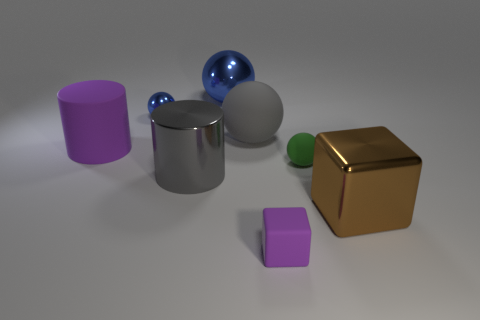Subtract all small green balls. How many balls are left? 3 Subtract all purple cylinders. How many cylinders are left? 1 Add 2 small red metal objects. How many objects exist? 10 Subtract all cylinders. How many objects are left? 6 Subtract all green cylinders. How many brown blocks are left? 1 Subtract all cyan metallic objects. Subtract all large gray rubber objects. How many objects are left? 7 Add 3 blue balls. How many blue balls are left? 5 Add 7 tiny purple blocks. How many tiny purple blocks exist? 8 Subtract 0 green cylinders. How many objects are left? 8 Subtract 2 cubes. How many cubes are left? 0 